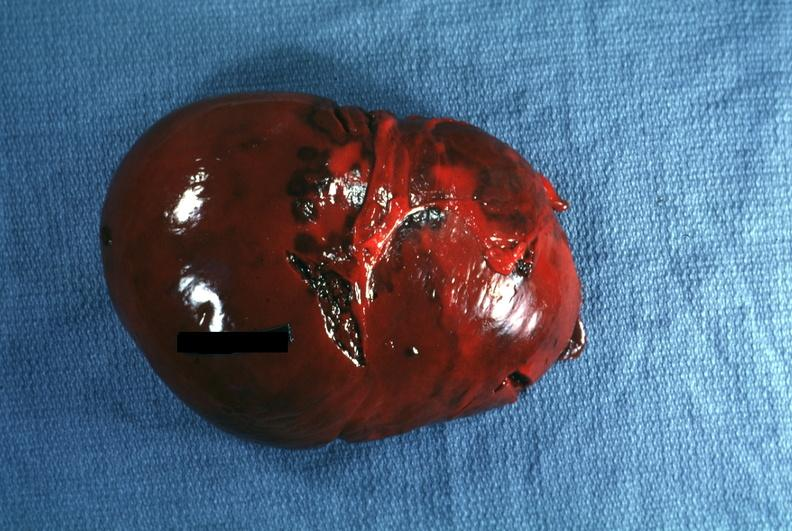does this image show external view several capsule lacerations easily seen?
Answer the question using a single word or phrase. Yes 